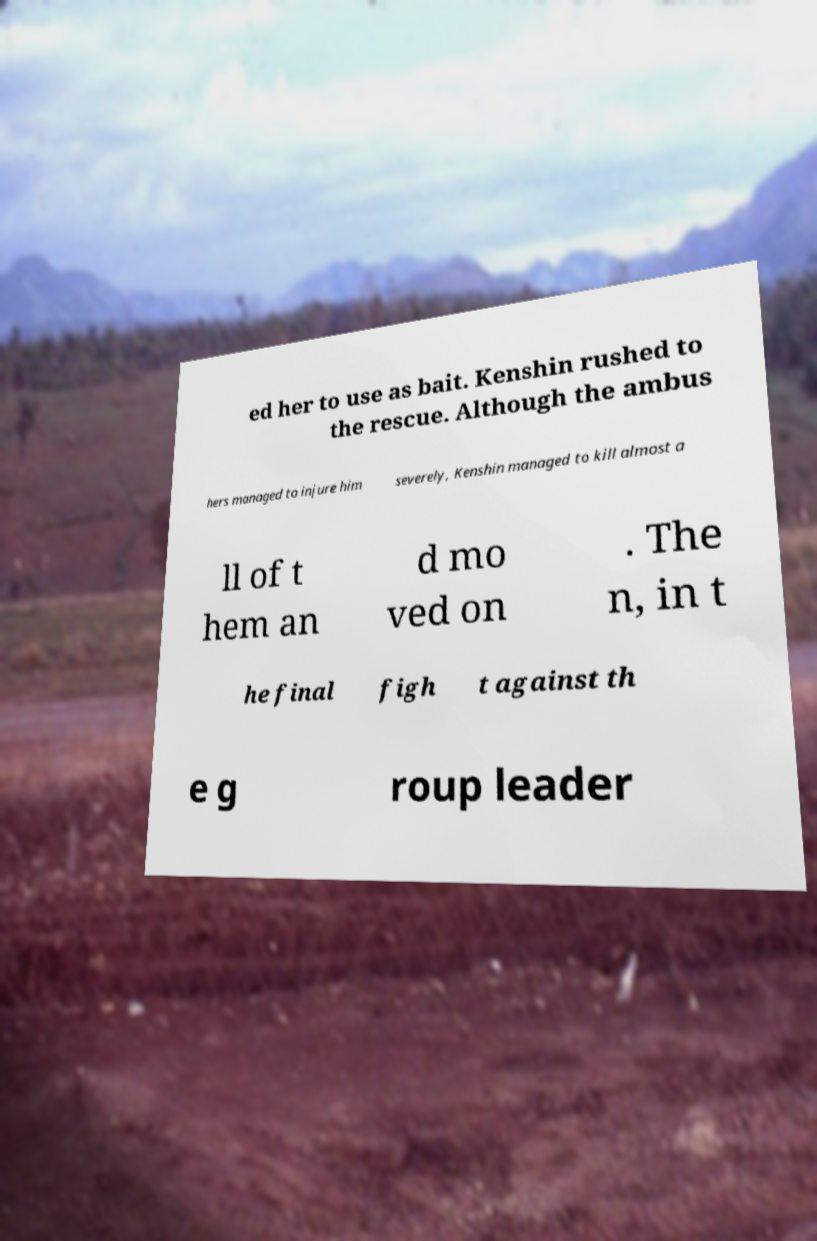Please identify and transcribe the text found in this image. ed her to use as bait. Kenshin rushed to the rescue. Although the ambus hers managed to injure him severely, Kenshin managed to kill almost a ll of t hem an d mo ved on . The n, in t he final figh t against th e g roup leader 